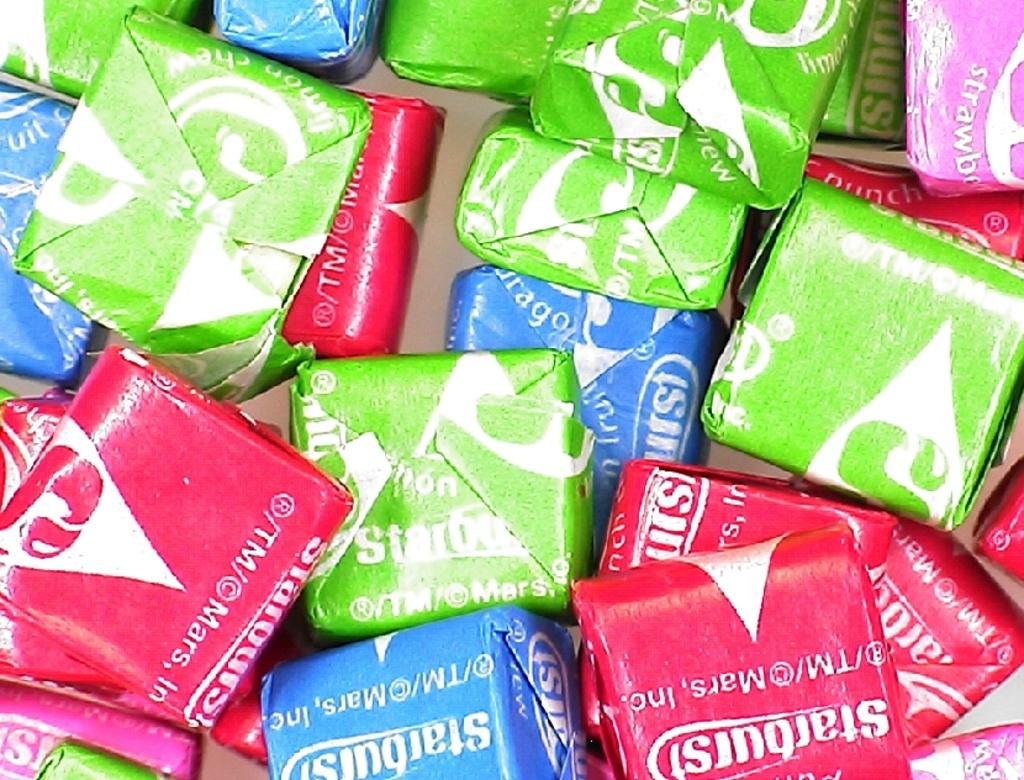What type of food item is present in the image? There are chocolate covers in the image. How many different colors can be seen on the chocolate covers? The chocolate covers have different colors, including red, blue, green, and pink. How many docks are visible in the image? There are no docks present in the image; it features chocolate covers with different colors. 